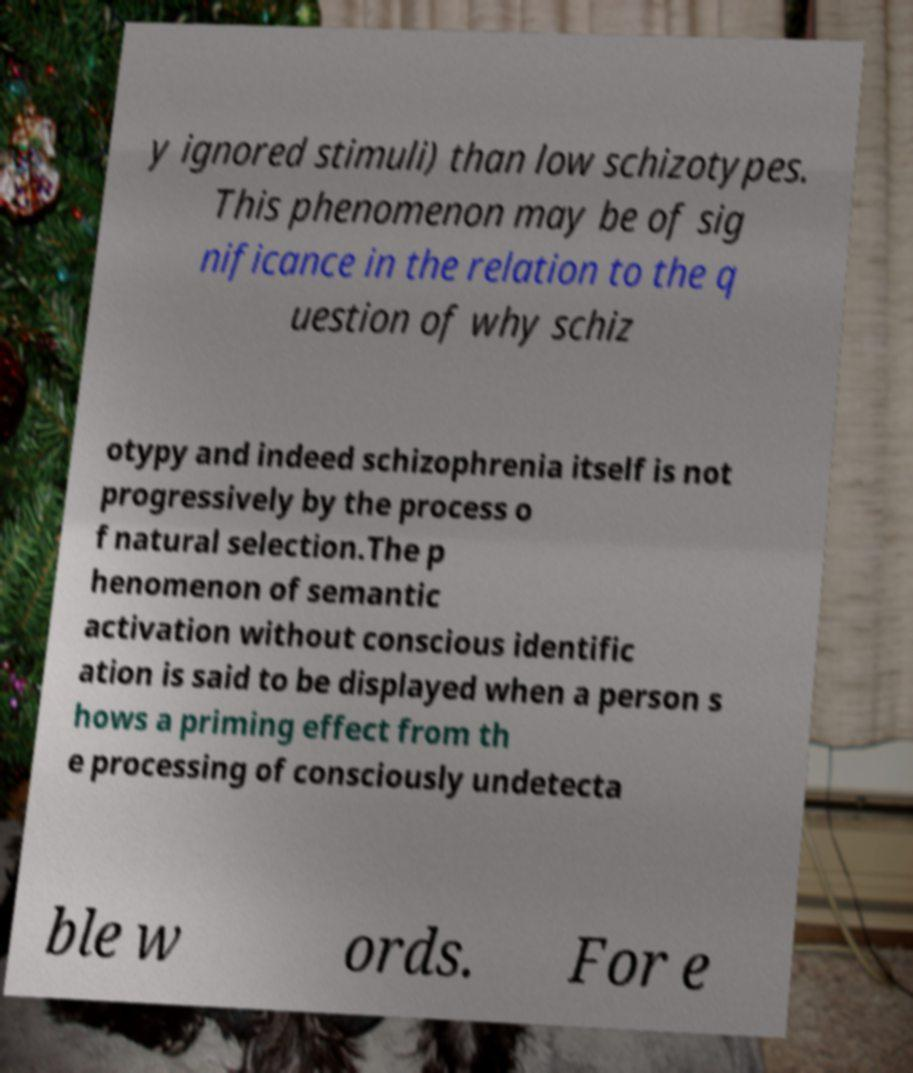For documentation purposes, I need the text within this image transcribed. Could you provide that? y ignored stimuli) than low schizotypes. This phenomenon may be of sig nificance in the relation to the q uestion of why schiz otypy and indeed schizophrenia itself is not progressively by the process o f natural selection.The p henomenon of semantic activation without conscious identific ation is said to be displayed when a person s hows a priming effect from th e processing of consciously undetecta ble w ords. For e 